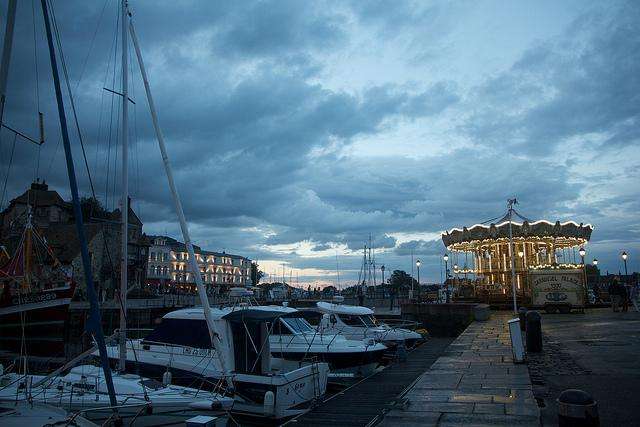What carved imagery animal is likely found on the amusement ride shown here?

Choices:
A) horse
B) rabbits
C) dogs
D) cats horse 